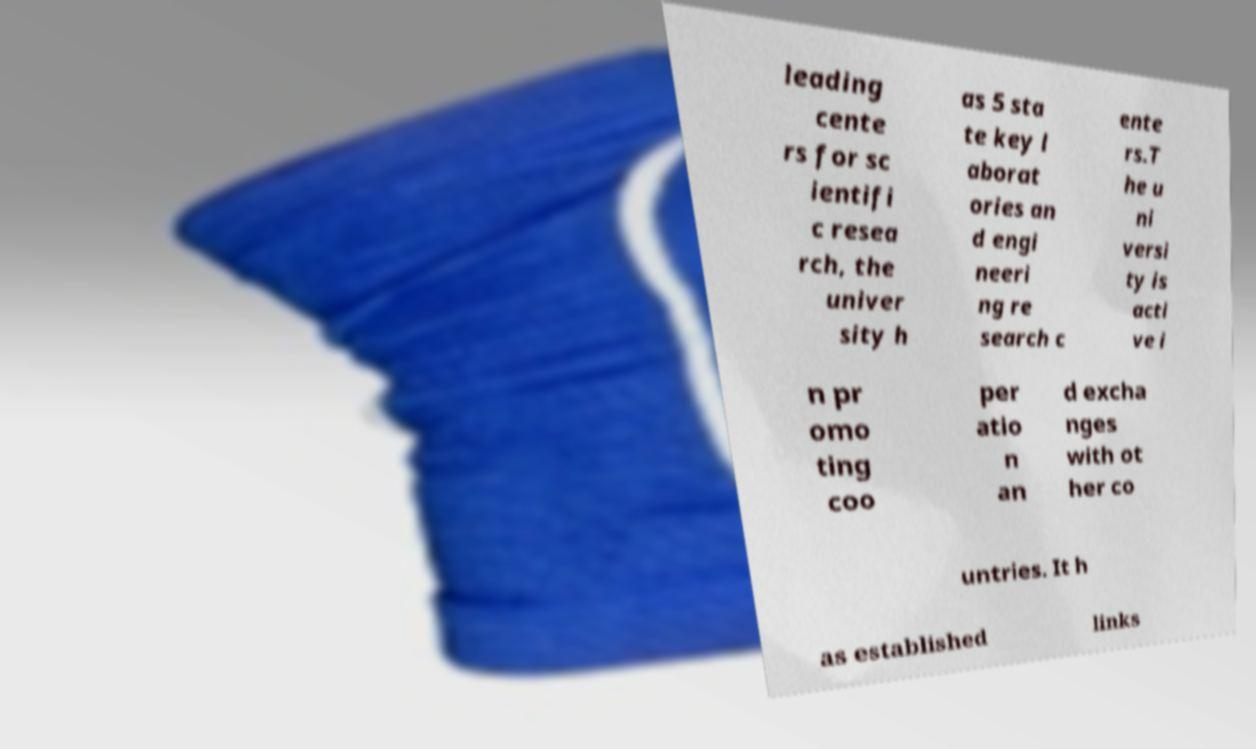Can you read and provide the text displayed in the image?This photo seems to have some interesting text. Can you extract and type it out for me? leading cente rs for sc ientifi c resea rch, the univer sity h as 5 sta te key l aborat ories an d engi neeri ng re search c ente rs.T he u ni versi ty is acti ve i n pr omo ting coo per atio n an d excha nges with ot her co untries. It h as established links 